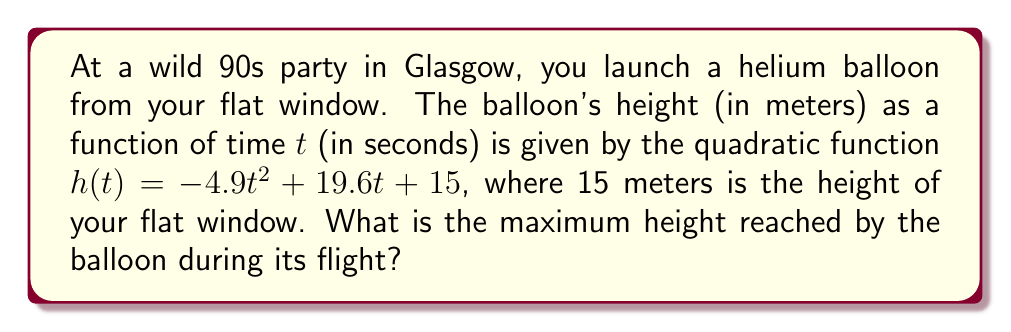Can you answer this question? To find the maximum height of the balloon's trajectory, we need to follow these steps:

1) The quadratic function is in the form $h(t) = -4.9t^2 + 19.6t + 15$, which is a parabola opening downwards (because the coefficient of $t^2$ is negative).

2) For a quadratic function $f(x) = ax^2 + bx + c$, the vertex formula gives us the x-coordinate of the vertex:

   $t = -\frac{b}{2a}$

3) In our case, $a = -4.9$ and $b = 19.6$. Let's substitute these values:

   $t = -\frac{19.6}{2(-4.9)} = \frac{19.6}{9.8} = 2$

4) This means the balloon reaches its maximum height 2 seconds after launch.

5) To find the maximum height, we need to calculate $h(2)$:

   $h(2) = -4.9(2)^2 + 19.6(2) + 15$
   $    = -4.9(4) + 39.2 + 15$
   $    = -19.6 + 39.2 + 15$
   $    = 34.6$

Therefore, the maximum height reached by the balloon is 34.6 meters.
Answer: The maximum height reached by the balloon is 34.6 meters. 